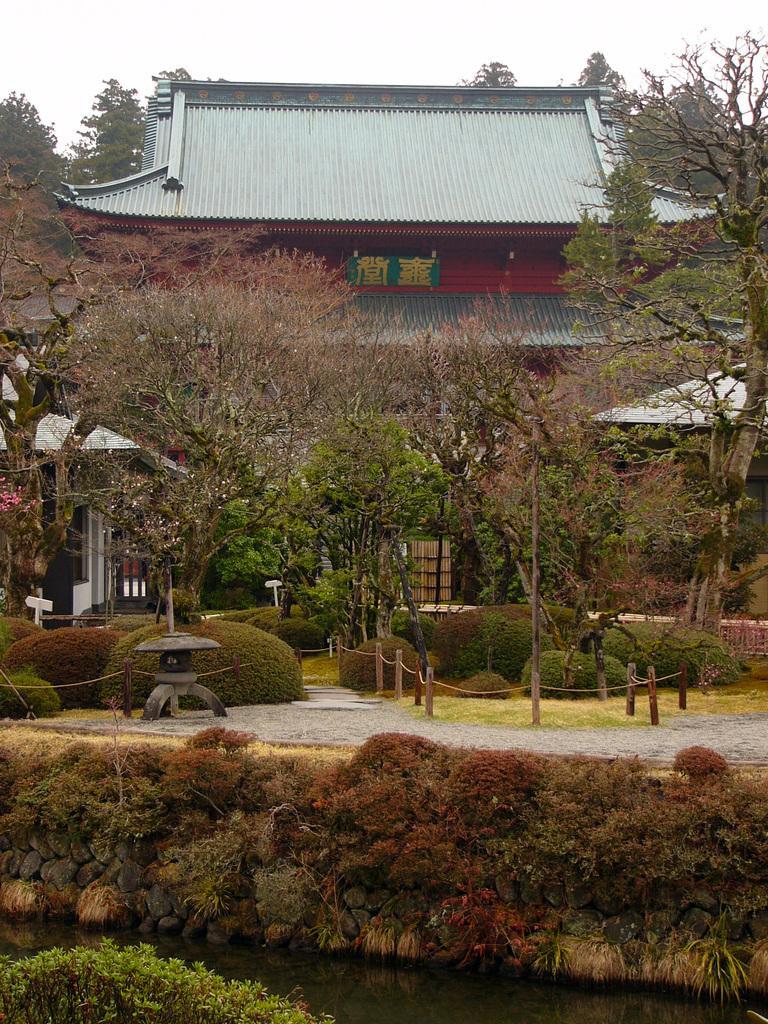Can you describe this image briefly? In this picture there is a building and there are trees and plants in front of it and there are some other trees in the background. 